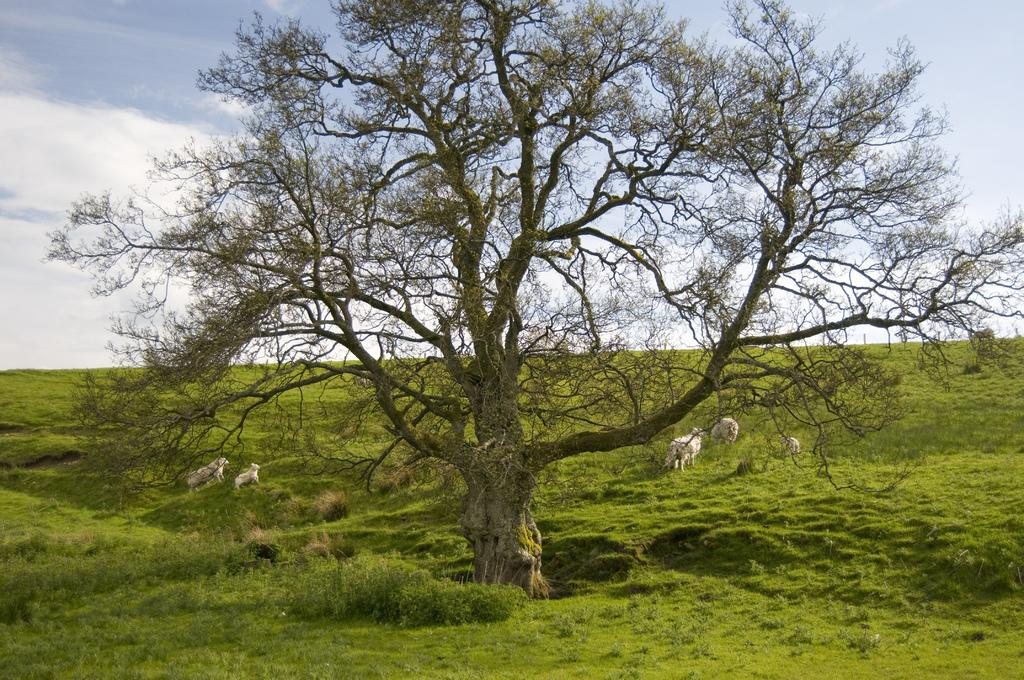What is the main subject in the center of the image? There is a tree in the center of the image. What can be seen in the background of the image? There are animals in the background of the image. What type of vegetation is present on the ground in the image? There is grass on the ground in the image. How would you describe the sky in the image? The sky is cloudy in the image. What type of car can be seen parked next to the tree in the image? There is no car present in the image; it features a tree, animals in the background, grass on the ground, and a cloudy sky. 